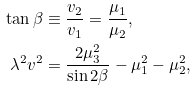<formula> <loc_0><loc_0><loc_500><loc_500>\tan \beta & \equiv \frac { v _ { 2 } } { v _ { 1 } } = \frac { \mu _ { 1 } } { \mu _ { 2 } } , \\ \lambda ^ { 2 } v ^ { 2 } & = \frac { 2 \mu _ { 3 } ^ { 2 } } { \sin 2 \beta } - \mu _ { 1 } ^ { 2 } - \mu _ { 2 } ^ { 2 } ,</formula> 